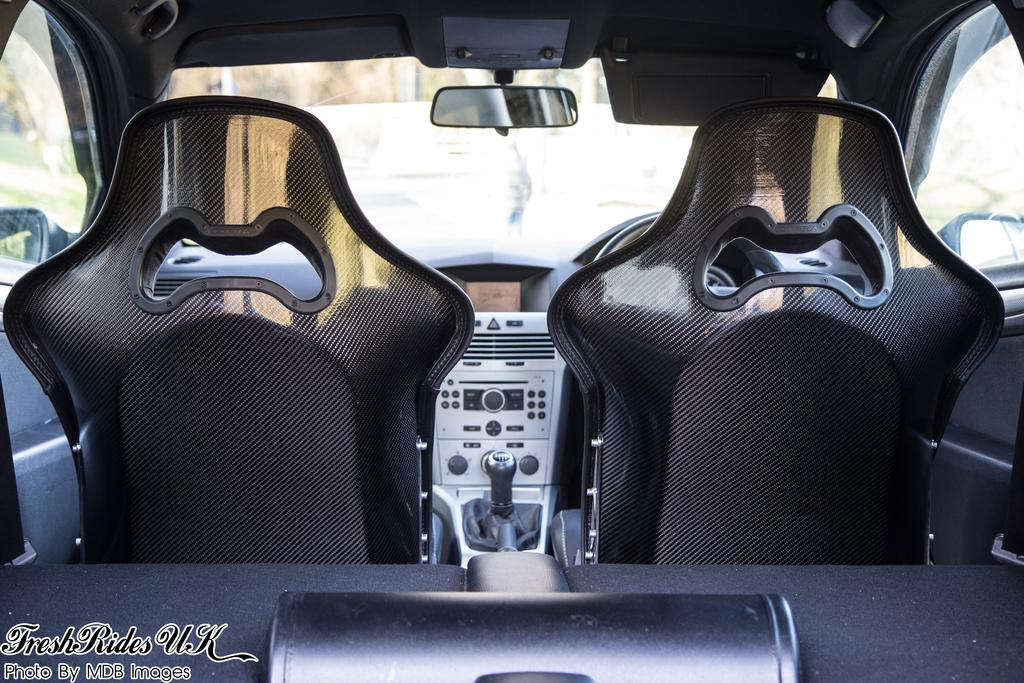What type of location is depicted in the image? The image shows an inside view of a car. How many seats are visible in the car? There are two seats in the car. What is the driver's primary control in the car? The steering wheel is visible in the image. What instrument is used to measure the car's speed? A speedometer is present in the image. What other parts of a car can be seen in the image? Other parts of a car are visible in the image. What can be seen outside the car? Cars outside the car and trees are visible outside the car. What type of bean is being roasted on the dashboard of the car? There is no bean present in the image, and the dashboard does not show any signs of bean roasting. 